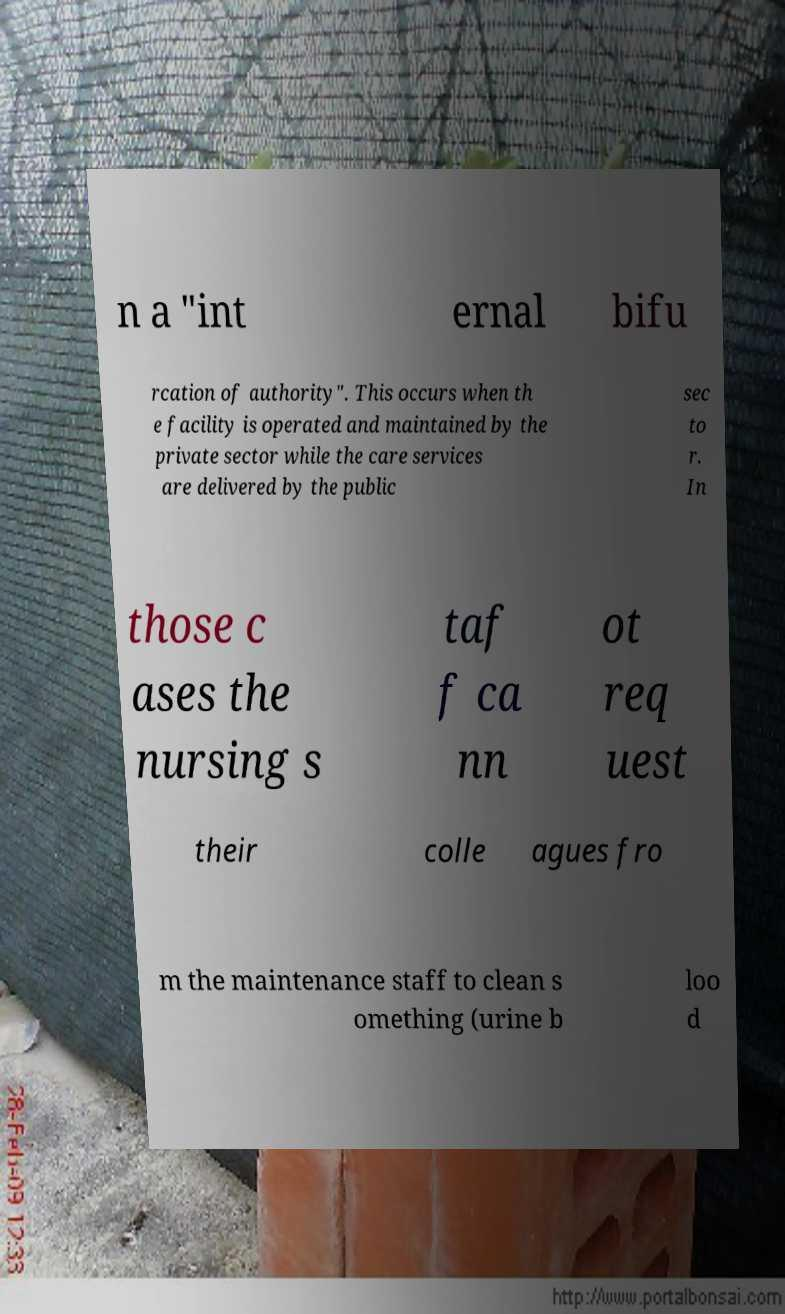Could you assist in decoding the text presented in this image and type it out clearly? n a "int ernal bifu rcation of authority". This occurs when th e facility is operated and maintained by the private sector while the care services are delivered by the public sec to r. In those c ases the nursing s taf f ca nn ot req uest their colle agues fro m the maintenance staff to clean s omething (urine b loo d 